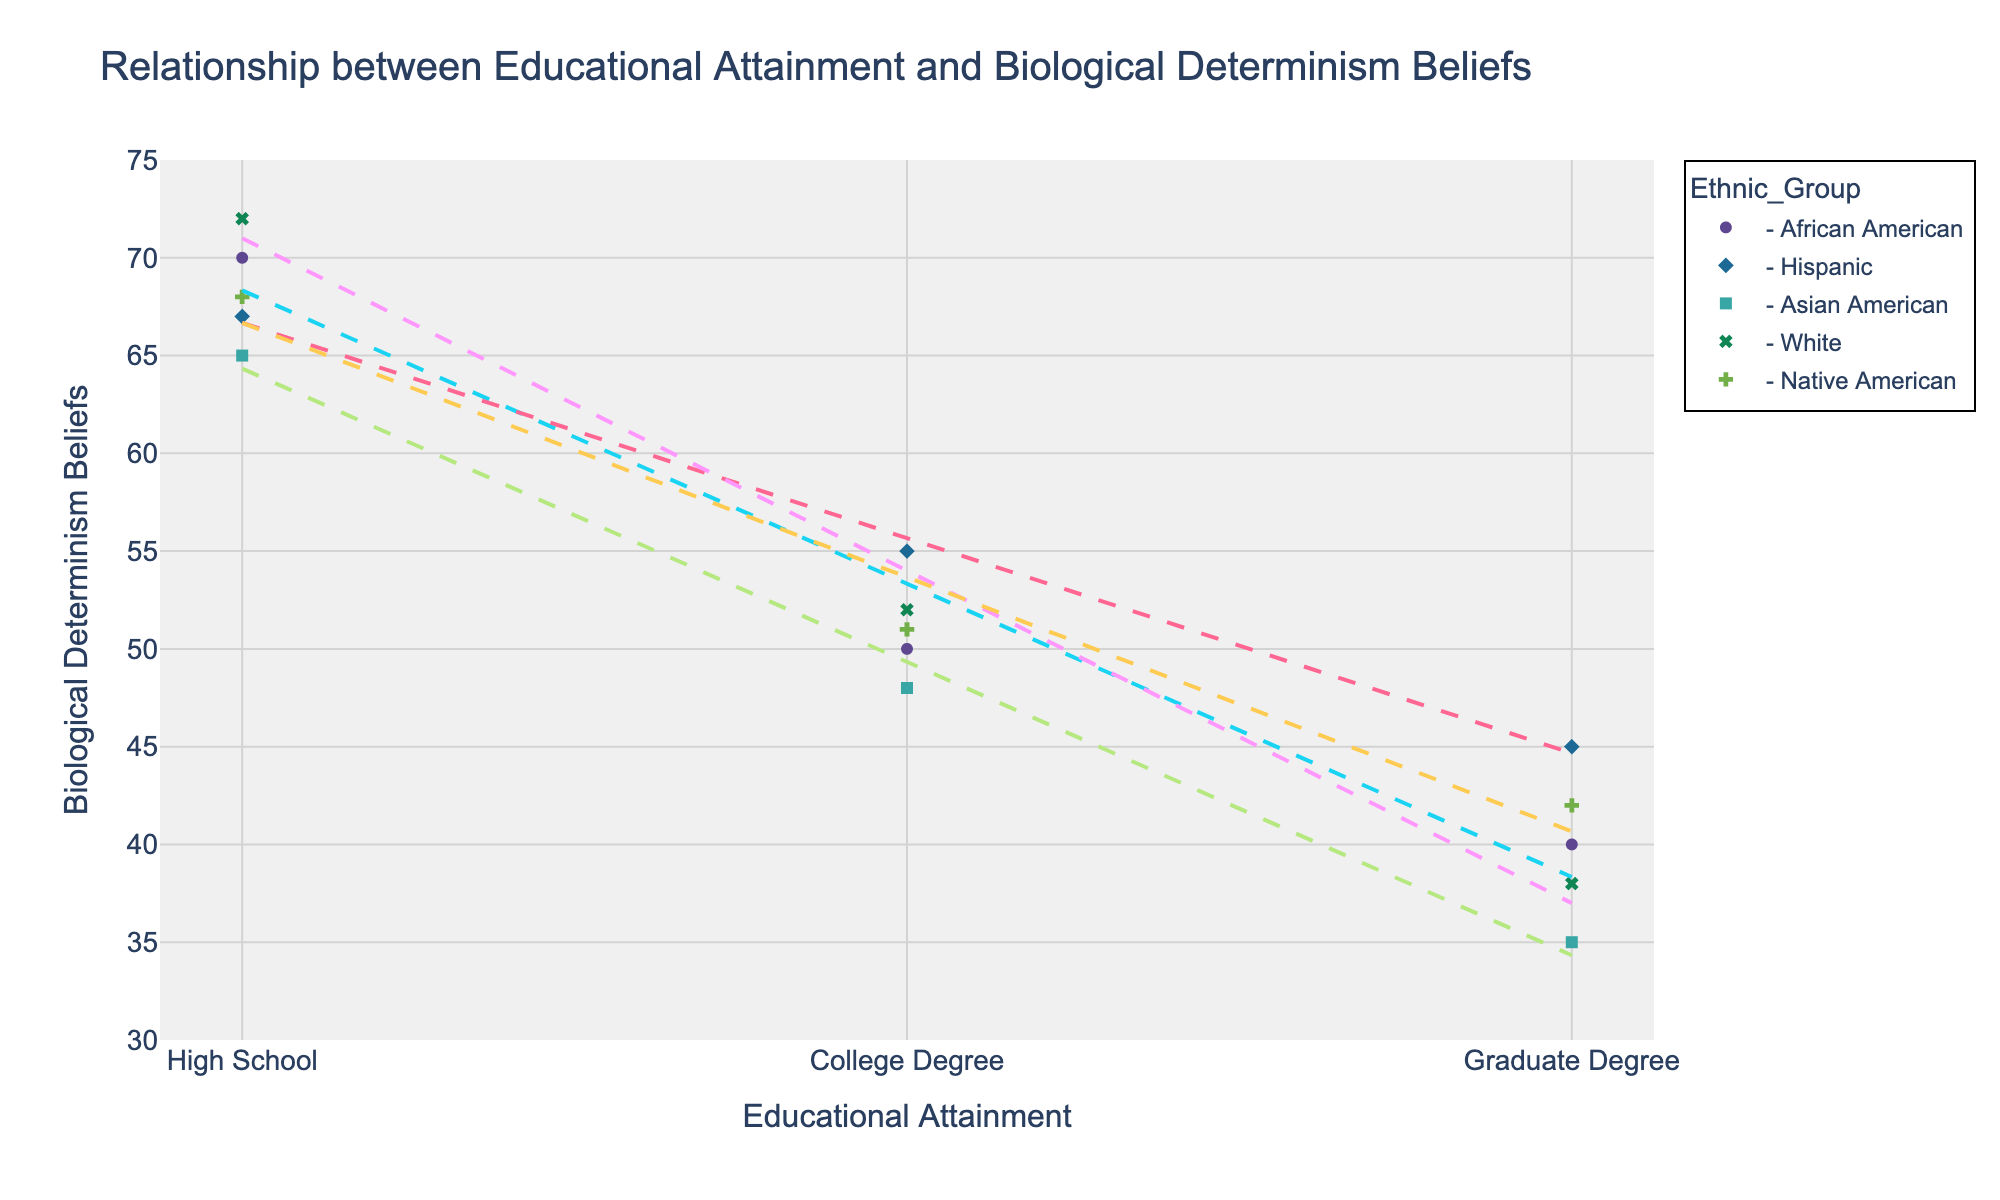What's the title of the graph? The title is displayed prominently at the top of the graph. It often provides a summary of what the graph is depicting.
Answer: Relationship between Educational Attainment and Biological Determinism Beliefs How many ethnic groups are represented in the figure? The legend on the right side of the graph displays the different ethnic groups, each with a unique color and symbol. Count the number of different groups listed.
Answer: 5 Which ethnic group has the steepest trend line in terms of decreasing belief in biological determinism with increasing educational attainment? Compare the slopes of the trend lines for each ethnic group. The steeper the slope, the more significant the decrease in beliefs with increasing education.
Answer: Asian American What is the biological determinism belief value for White individuals with a Graduate Degree? Locate the data points for White individuals. Identify the point corresponding to the Graduate Degree educational level and note the y-axis value.
Answer: 38 Which ethnic group shows the highest belief in biological determinism at the High School educational level? Identify the data points for the High School educational level for each ethnic group. Compare the y-axis values of these points.
Answer: White How does the belief in biological determinism for African American individuals change from High School to Graduate Degree? Find the data points for African American individuals at High School and Graduate Degree levels and note their y-axis values. Calculate the difference between these values.
Answer: Decreases from 70 to 40 On average, how does biological determinism belief at the College Degree level compare across all ethnic groups? Locate the data points at the College Degree level for all groups. Calculate the average y-axis value of these points.
Answer: (50 + 55 + 48 + 52 + 51) / 5 = 51.2 Which ethnic group's trend line is closest to being horizontal? A horizontal trend line indicates the least change in beliefs with increasing education. Compare the slopes of the lines; the one closest to zero is the most horizontal.
Answer: Native American Between Hispanic and Native American groups, which shows a greater decrease in biological determinism beliefs from High School to Graduate Degree? Find the data points for both groups at High School and Graduate Degree levels and calculate the difference for each. Compare the two deltas.
Answer: Hispanic What is the approximate difference in belief values at the College Degree level between African Americans and Asian Americans? Locate the College Degree points for both groups and note their y-axis values. Calculate the difference between these values.
Answer: 50 - 48 = 2 